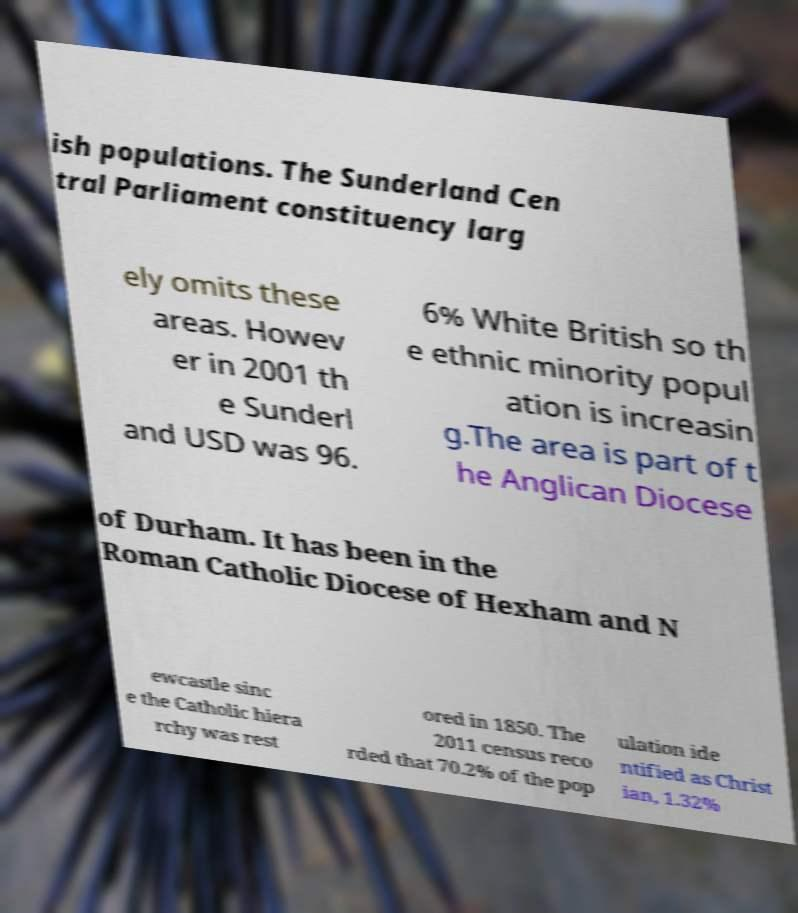For documentation purposes, I need the text within this image transcribed. Could you provide that? ish populations. The Sunderland Cen tral Parliament constituency larg ely omits these areas. Howev er in 2001 th e Sunderl and USD was 96. 6% White British so th e ethnic minority popul ation is increasin g.The area is part of t he Anglican Diocese of Durham. It has been in the Roman Catholic Diocese of Hexham and N ewcastle sinc e the Catholic hiera rchy was rest ored in 1850. The 2011 census reco rded that 70.2% of the pop ulation ide ntified as Christ ian, 1.32% 